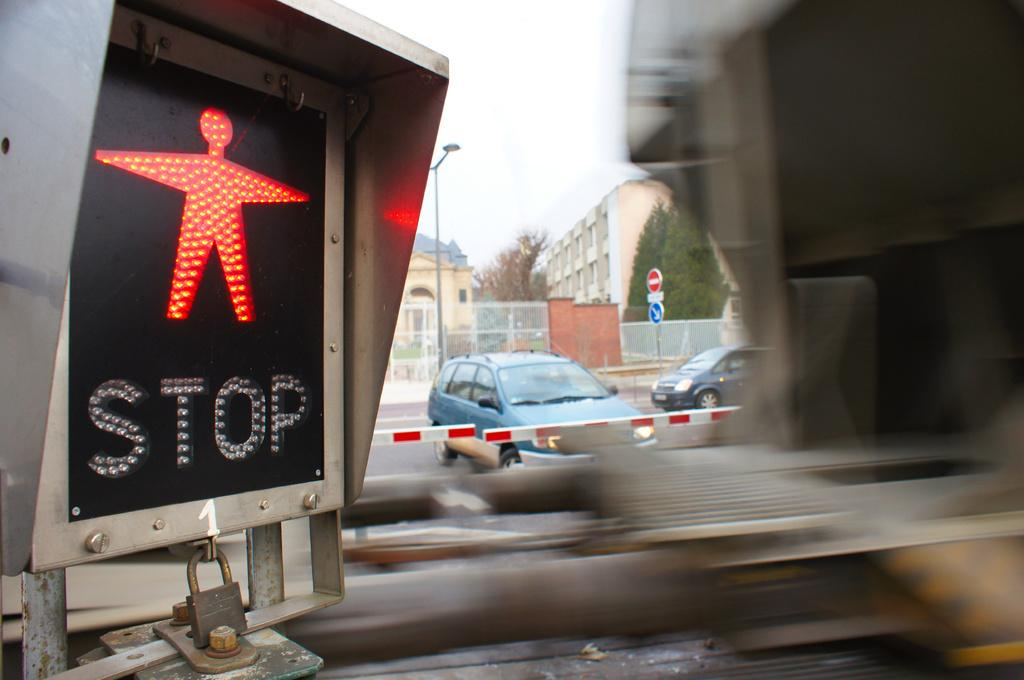<image>
Give a short and clear explanation of the subsequent image. Traffic light shows "stop" for pedestrians as a vehicle moves behind it. 